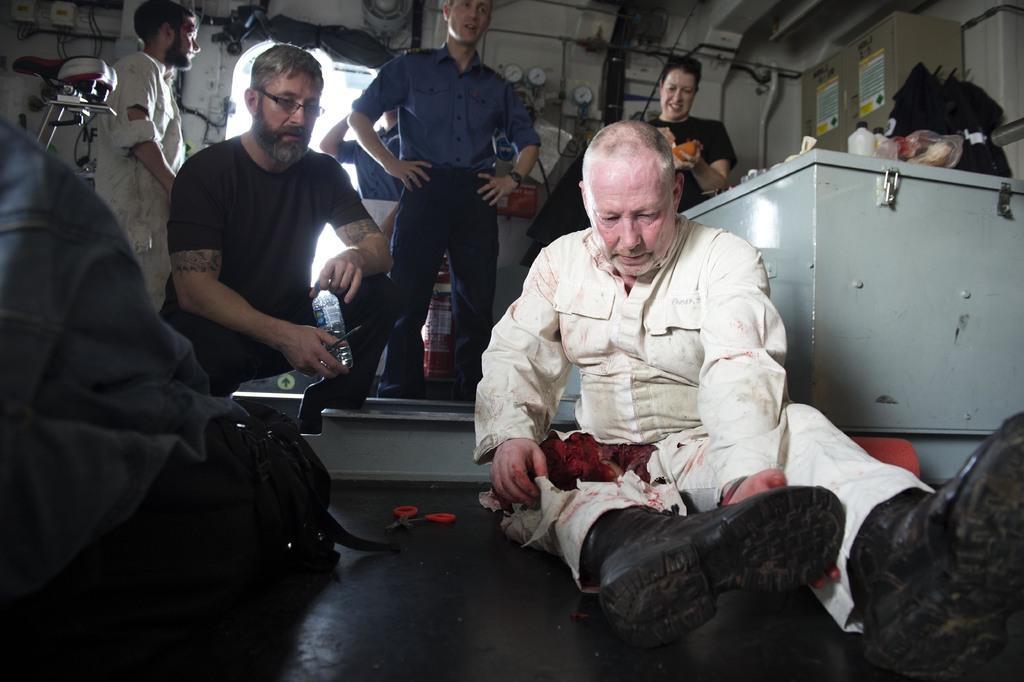Could you give a brief overview of what you see in this image? In this image we can see a man sitting on the floor. We can also see the people standing. There is a man holding the bottle. On the left we can see the bag and a person. We can also see the scissor and some other objects. We can also see the wires, pipe and also the text papers attached to the wall. 